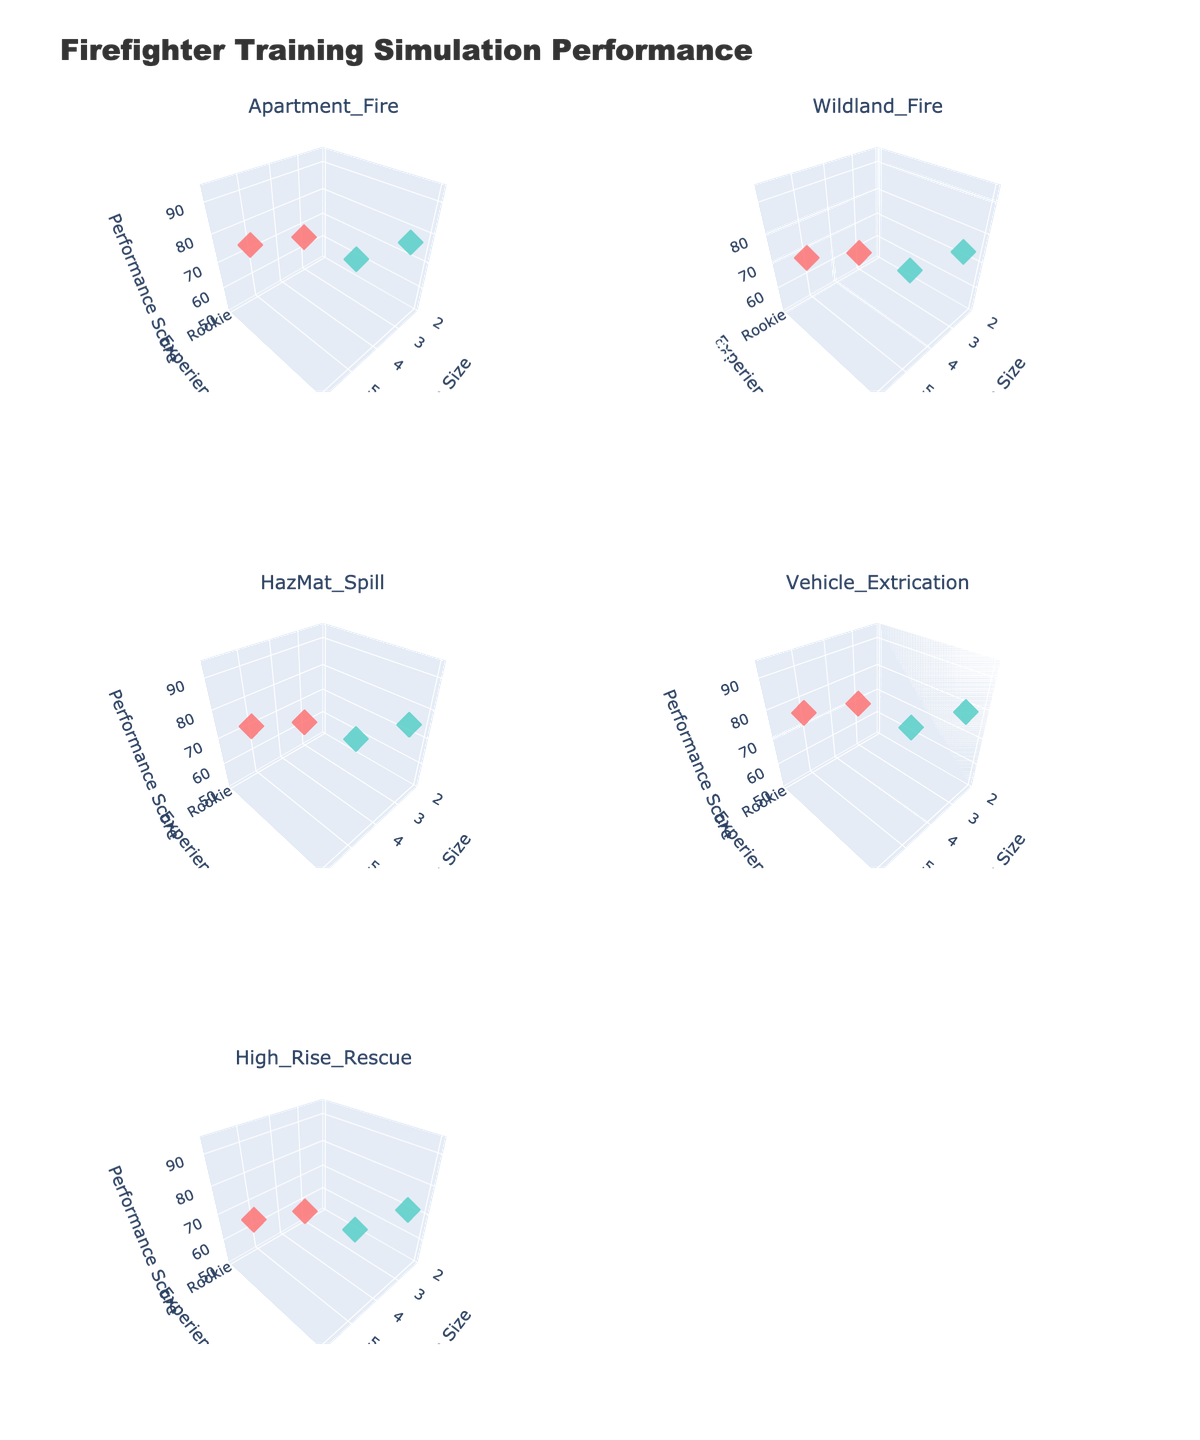What scenarios are displayed in the figure? The subplot titles indicate the different scenarios being evaluated. These can be found at the top of each subplot.
Answer: Apartment Fire, Wildland Fire, HazMat Spill, Vehicle Extrication, High Rise Rescue What are the axes titles across all subplots? The axes titles for all subplots indicate the three dimensions measured in the figure. These are visible in each subplot and indicate what each axis represents.
Answer: Team Size, Experience Level, Performance Score How does performance score generally change with experience level across scenarios? By examining the different colors for Rookie and Veteran groups within each subplot, we can see how performance scores generally vary for each experience level.
Answer: Veterans generally have higher performance scores than Rookies In the Apartment Fire scenario, how does the performance score of a 3-person team of Rookies compare to a 3-person team of Veterans? Look at the markers for the Apartment Fire subplot corresponding to a Team Size of 3 and compare the Performance Score for Rookies (red color) and Veterans (blue color).
Answer: Rookie: 65, Veteran: 82 Which scenario has the lowest performance score and for which team size and experience level? Identify the lowest z-axis (Performance Score) value across all subplots and note the corresponding Team Size and Experience Level at that point.
Answer: High Rise Rescue, 3-person team, Rookie Does increasing the team size always result in a higher performance score for both experience levels? Compare the z-axis values (Performance Scores) within each subplot for both experience levels (Rookie and Veteran) as the x-axis (Team Size) increases.
Answer: No, but generally yes For the Wildland Fire scenario, is there a significant difference in performance scores between Rookies and Veterans for a 5-person team? Check the Wildland Fire subplot for differences in Performance Scores (z-axis values) between Rookies and Veterans for a Team Size of 5.
Answer: Yes, Veterans have higher scores Which experience level yields the highest performance score across all scenarios and team sizes? Identify the highest z-axis value (Performance Score) point across all subplots and note the Experience Level at that point.
Answer: Veteran What is the performance score range in the Vehicle Extrication scenario for both Rookies and Veterans? Examine the Vehicle Extrication subplot and identify the minimum and maximum Performance Scores for both Rookies and Veterans.
Answer: Rookie: 69-75, Veteran: 84-90 Compare the overall performance scores between the HazMat Spill and High Rise Rescue scenarios for 5-person teams of Veterans. Look at the Performance Scores (z-axis values) in both the HazMat Spill and High Rise Rescue subplots for each Team Size of 5 and Experience Level Veteran (blue color).
Answer: HazMat Spill: 87, High Rise Rescue: 83 